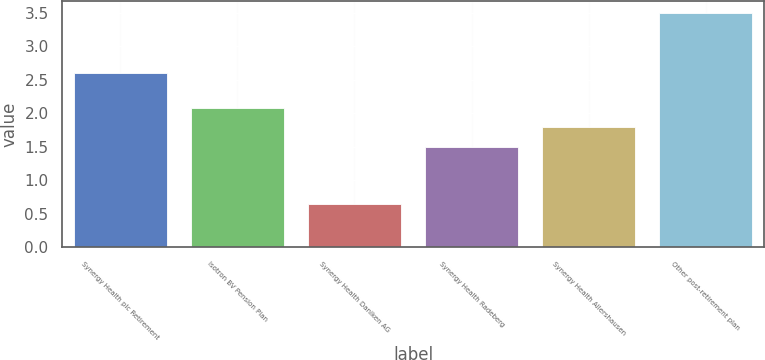Convert chart. <chart><loc_0><loc_0><loc_500><loc_500><bar_chart><fcel>Synergy Health plc Retirement<fcel>Isotron BV Pension Plan<fcel>Synergy Health Daniken AG<fcel>Synergy Health Radeberg<fcel>Synergy Health Allershausen<fcel>Other post-retirement plan<nl><fcel>2.6<fcel>2.08<fcel>0.65<fcel>1.5<fcel>1.79<fcel>3.5<nl></chart> 